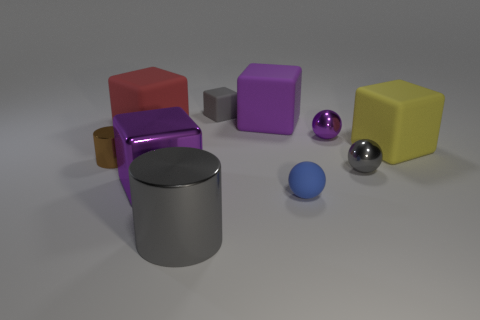Do the red rubber block and the metallic block have the same size?
Your answer should be very brief. Yes. What is the thing that is both behind the red block and in front of the tiny gray block made of?
Your answer should be compact. Rubber. What is the material of the yellow thing behind the blue matte ball?
Offer a very short reply. Rubber. Does the tiny purple shiny thing have the same shape as the small blue rubber thing?
Provide a succinct answer. Yes. There is a tiny gray matte thing; does it have the same shape as the purple thing that is in front of the yellow matte thing?
Make the answer very short. Yes. What material is the purple block that is in front of the big rubber thing that is on the left side of the big purple metallic cube made of?
Make the answer very short. Metal. Do the tiny metal object that is behind the large yellow matte thing and the block in front of the large yellow thing have the same color?
Offer a very short reply. Yes. There is a red rubber object that is the same shape as the big yellow matte object; what size is it?
Your answer should be compact. Large. Is there a object that has the same color as the tiny cube?
Your answer should be very brief. Yes. There is a tiny ball that is the same color as the metallic cube; what is its material?
Provide a short and direct response. Metal. 